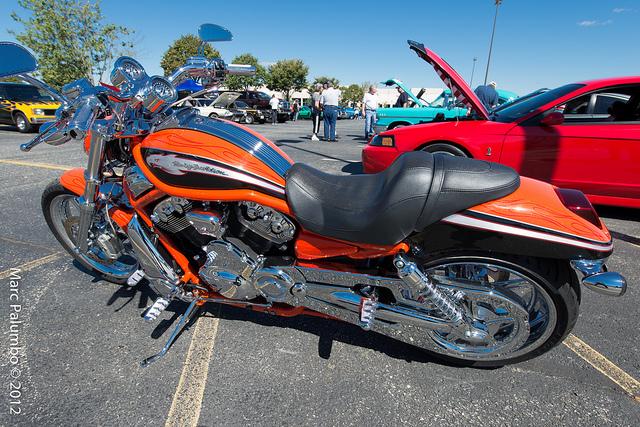What color are the lines on the road?
Write a very short answer. Yellow. How many wheels?
Answer briefly. 2. Does the vehicle have a chain?
Quick response, please. No. How many men are there?
Be succinct. 3. What color is the bike?
Be succinct. Orange. 